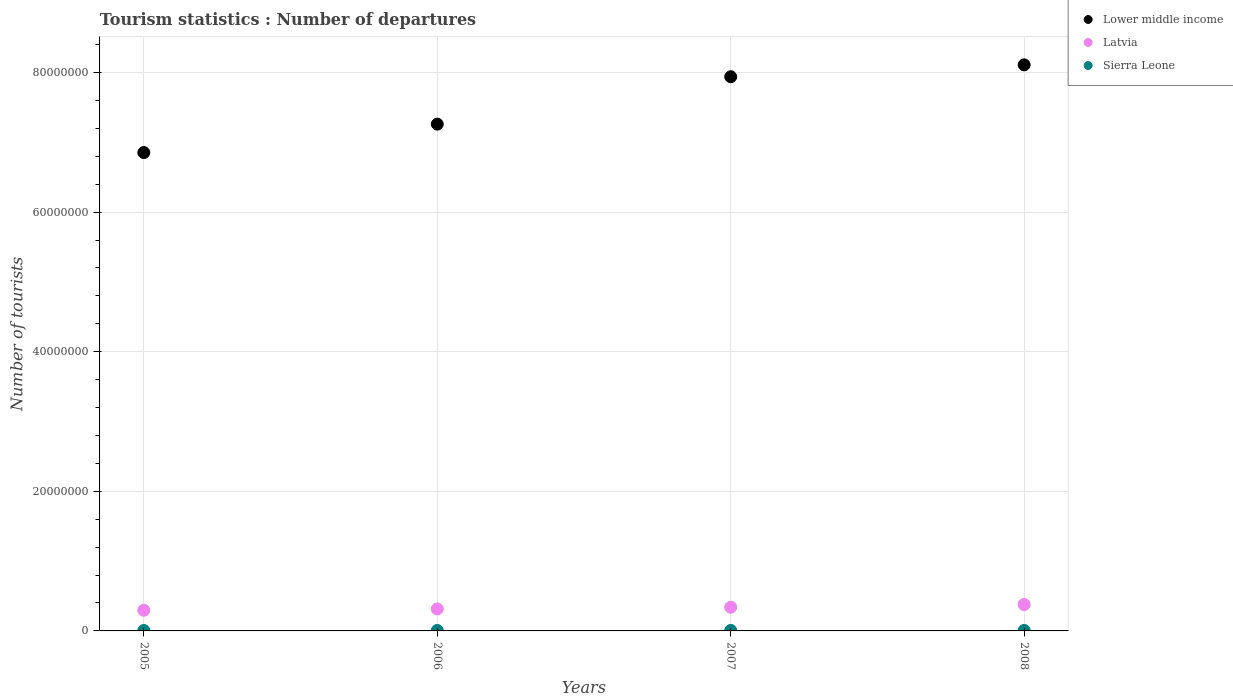How many different coloured dotlines are there?
Provide a succinct answer. 3. What is the number of tourist departures in Sierra Leone in 2006?
Give a very brief answer. 6.70e+04. Across all years, what is the maximum number of tourist departures in Latvia?
Give a very brief answer. 3.78e+06. Across all years, what is the minimum number of tourist departures in Lower middle income?
Offer a very short reply. 6.85e+07. What is the total number of tourist departures in Latvia in the graph?
Your answer should be compact. 1.33e+07. What is the difference between the number of tourist departures in Sierra Leone in 2005 and that in 2006?
Ensure brevity in your answer.  -4000. What is the difference between the number of tourist departures in Sierra Leone in 2007 and the number of tourist departures in Lower middle income in 2008?
Your answer should be compact. -8.10e+07. What is the average number of tourist departures in Latvia per year?
Ensure brevity in your answer.  3.32e+06. In the year 2008, what is the difference between the number of tourist departures in Lower middle income and number of tourist departures in Sierra Leone?
Make the answer very short. 8.10e+07. In how many years, is the number of tourist departures in Sierra Leone greater than 68000000?
Offer a very short reply. 0. What is the ratio of the number of tourist departures in Sierra Leone in 2005 to that in 2006?
Provide a succinct answer. 0.94. Is the number of tourist departures in Latvia in 2007 less than that in 2008?
Make the answer very short. Yes. What is the difference between the highest and the second highest number of tourist departures in Sierra Leone?
Keep it short and to the point. 2000. What is the difference between the highest and the lowest number of tourist departures in Lower middle income?
Offer a terse response. 1.26e+07. In how many years, is the number of tourist departures in Latvia greater than the average number of tourist departures in Latvia taken over all years?
Offer a very short reply. 2. Is the sum of the number of tourist departures in Lower middle income in 2006 and 2008 greater than the maximum number of tourist departures in Latvia across all years?
Make the answer very short. Yes. Does the graph contain any zero values?
Make the answer very short. No. How many legend labels are there?
Provide a succinct answer. 3. What is the title of the graph?
Your response must be concise. Tourism statistics : Number of departures. Does "Germany" appear as one of the legend labels in the graph?
Provide a succinct answer. No. What is the label or title of the X-axis?
Give a very brief answer. Years. What is the label or title of the Y-axis?
Keep it short and to the point. Number of tourists. What is the Number of tourists of Lower middle income in 2005?
Your answer should be compact. 6.85e+07. What is the Number of tourists in Latvia in 2005?
Your answer should be very brief. 2.96e+06. What is the Number of tourists of Sierra Leone in 2005?
Offer a very short reply. 6.30e+04. What is the Number of tourists of Lower middle income in 2006?
Offer a terse response. 7.26e+07. What is the Number of tourists in Latvia in 2006?
Provide a succinct answer. 3.15e+06. What is the Number of tourists in Sierra Leone in 2006?
Give a very brief answer. 6.70e+04. What is the Number of tourists in Lower middle income in 2007?
Give a very brief answer. 7.94e+07. What is the Number of tourists in Latvia in 2007?
Provide a succinct answer. 3.40e+06. What is the Number of tourists of Sierra Leone in 2007?
Make the answer very short. 7.10e+04. What is the Number of tourists in Lower middle income in 2008?
Keep it short and to the point. 8.11e+07. What is the Number of tourists of Latvia in 2008?
Your response must be concise. 3.78e+06. What is the Number of tourists in Sierra Leone in 2008?
Ensure brevity in your answer.  7.30e+04. Across all years, what is the maximum Number of tourists of Lower middle income?
Your answer should be compact. 8.11e+07. Across all years, what is the maximum Number of tourists in Latvia?
Your answer should be very brief. 3.78e+06. Across all years, what is the maximum Number of tourists in Sierra Leone?
Your answer should be very brief. 7.30e+04. Across all years, what is the minimum Number of tourists of Lower middle income?
Ensure brevity in your answer.  6.85e+07. Across all years, what is the minimum Number of tourists of Latvia?
Provide a succinct answer. 2.96e+06. Across all years, what is the minimum Number of tourists of Sierra Leone?
Ensure brevity in your answer.  6.30e+04. What is the total Number of tourists of Lower middle income in the graph?
Offer a very short reply. 3.02e+08. What is the total Number of tourists of Latvia in the graph?
Offer a very short reply. 1.33e+07. What is the total Number of tourists in Sierra Leone in the graph?
Give a very brief answer. 2.74e+05. What is the difference between the Number of tourists in Lower middle income in 2005 and that in 2006?
Ensure brevity in your answer.  -4.07e+06. What is the difference between the Number of tourists of Latvia in 2005 and that in 2006?
Your answer should be very brief. -1.92e+05. What is the difference between the Number of tourists in Sierra Leone in 2005 and that in 2006?
Your answer should be very brief. -4000. What is the difference between the Number of tourists in Lower middle income in 2005 and that in 2007?
Provide a short and direct response. -1.09e+07. What is the difference between the Number of tourists in Latvia in 2005 and that in 2007?
Your answer should be very brief. -4.39e+05. What is the difference between the Number of tourists of Sierra Leone in 2005 and that in 2007?
Give a very brief answer. -8000. What is the difference between the Number of tourists of Lower middle income in 2005 and that in 2008?
Make the answer very short. -1.26e+07. What is the difference between the Number of tourists in Latvia in 2005 and that in 2008?
Your response must be concise. -8.23e+05. What is the difference between the Number of tourists of Lower middle income in 2006 and that in 2007?
Give a very brief answer. -6.79e+06. What is the difference between the Number of tourists of Latvia in 2006 and that in 2007?
Ensure brevity in your answer.  -2.47e+05. What is the difference between the Number of tourists in Sierra Leone in 2006 and that in 2007?
Offer a very short reply. -4000. What is the difference between the Number of tourists in Lower middle income in 2006 and that in 2008?
Make the answer very short. -8.49e+06. What is the difference between the Number of tourists in Latvia in 2006 and that in 2008?
Provide a short and direct response. -6.31e+05. What is the difference between the Number of tourists of Sierra Leone in 2006 and that in 2008?
Keep it short and to the point. -6000. What is the difference between the Number of tourists of Lower middle income in 2007 and that in 2008?
Keep it short and to the point. -1.70e+06. What is the difference between the Number of tourists in Latvia in 2007 and that in 2008?
Give a very brief answer. -3.84e+05. What is the difference between the Number of tourists in Sierra Leone in 2007 and that in 2008?
Make the answer very short. -2000. What is the difference between the Number of tourists in Lower middle income in 2005 and the Number of tourists in Latvia in 2006?
Give a very brief answer. 6.54e+07. What is the difference between the Number of tourists in Lower middle income in 2005 and the Number of tourists in Sierra Leone in 2006?
Your answer should be compact. 6.85e+07. What is the difference between the Number of tourists of Latvia in 2005 and the Number of tourists of Sierra Leone in 2006?
Keep it short and to the point. 2.89e+06. What is the difference between the Number of tourists of Lower middle income in 2005 and the Number of tourists of Latvia in 2007?
Offer a very short reply. 6.51e+07. What is the difference between the Number of tourists in Lower middle income in 2005 and the Number of tourists in Sierra Leone in 2007?
Your answer should be very brief. 6.85e+07. What is the difference between the Number of tourists of Latvia in 2005 and the Number of tourists of Sierra Leone in 2007?
Offer a very short reply. 2.89e+06. What is the difference between the Number of tourists in Lower middle income in 2005 and the Number of tourists in Latvia in 2008?
Make the answer very short. 6.47e+07. What is the difference between the Number of tourists in Lower middle income in 2005 and the Number of tourists in Sierra Leone in 2008?
Offer a terse response. 6.85e+07. What is the difference between the Number of tourists in Latvia in 2005 and the Number of tourists in Sierra Leone in 2008?
Make the answer very short. 2.89e+06. What is the difference between the Number of tourists of Lower middle income in 2006 and the Number of tourists of Latvia in 2007?
Your response must be concise. 6.92e+07. What is the difference between the Number of tourists in Lower middle income in 2006 and the Number of tourists in Sierra Leone in 2007?
Give a very brief answer. 7.25e+07. What is the difference between the Number of tourists in Latvia in 2006 and the Number of tourists in Sierra Leone in 2007?
Provide a succinct answer. 3.08e+06. What is the difference between the Number of tourists of Lower middle income in 2006 and the Number of tourists of Latvia in 2008?
Provide a short and direct response. 6.88e+07. What is the difference between the Number of tourists of Lower middle income in 2006 and the Number of tourists of Sierra Leone in 2008?
Give a very brief answer. 7.25e+07. What is the difference between the Number of tourists in Latvia in 2006 and the Number of tourists in Sierra Leone in 2008?
Offer a terse response. 3.08e+06. What is the difference between the Number of tourists in Lower middle income in 2007 and the Number of tourists in Latvia in 2008?
Offer a terse response. 7.56e+07. What is the difference between the Number of tourists in Lower middle income in 2007 and the Number of tourists in Sierra Leone in 2008?
Your answer should be very brief. 7.93e+07. What is the difference between the Number of tourists of Latvia in 2007 and the Number of tourists of Sierra Leone in 2008?
Offer a terse response. 3.32e+06. What is the average Number of tourists in Lower middle income per year?
Make the answer very short. 7.54e+07. What is the average Number of tourists of Latvia per year?
Offer a terse response. 3.32e+06. What is the average Number of tourists in Sierra Leone per year?
Your response must be concise. 6.85e+04. In the year 2005, what is the difference between the Number of tourists of Lower middle income and Number of tourists of Latvia?
Your response must be concise. 6.56e+07. In the year 2005, what is the difference between the Number of tourists in Lower middle income and Number of tourists in Sierra Leone?
Provide a succinct answer. 6.85e+07. In the year 2005, what is the difference between the Number of tourists in Latvia and Number of tourists in Sierra Leone?
Keep it short and to the point. 2.90e+06. In the year 2006, what is the difference between the Number of tourists of Lower middle income and Number of tourists of Latvia?
Offer a very short reply. 6.94e+07. In the year 2006, what is the difference between the Number of tourists of Lower middle income and Number of tourists of Sierra Leone?
Provide a succinct answer. 7.25e+07. In the year 2006, what is the difference between the Number of tourists in Latvia and Number of tourists in Sierra Leone?
Ensure brevity in your answer.  3.08e+06. In the year 2007, what is the difference between the Number of tourists in Lower middle income and Number of tourists in Latvia?
Make the answer very short. 7.60e+07. In the year 2007, what is the difference between the Number of tourists in Lower middle income and Number of tourists in Sierra Leone?
Your answer should be compact. 7.93e+07. In the year 2007, what is the difference between the Number of tourists in Latvia and Number of tourists in Sierra Leone?
Keep it short and to the point. 3.33e+06. In the year 2008, what is the difference between the Number of tourists in Lower middle income and Number of tourists in Latvia?
Offer a very short reply. 7.73e+07. In the year 2008, what is the difference between the Number of tourists of Lower middle income and Number of tourists of Sierra Leone?
Provide a short and direct response. 8.10e+07. In the year 2008, what is the difference between the Number of tourists of Latvia and Number of tourists of Sierra Leone?
Your answer should be very brief. 3.71e+06. What is the ratio of the Number of tourists of Lower middle income in 2005 to that in 2006?
Offer a terse response. 0.94. What is the ratio of the Number of tourists of Latvia in 2005 to that in 2006?
Make the answer very short. 0.94. What is the ratio of the Number of tourists of Sierra Leone in 2005 to that in 2006?
Your answer should be very brief. 0.94. What is the ratio of the Number of tourists of Lower middle income in 2005 to that in 2007?
Give a very brief answer. 0.86. What is the ratio of the Number of tourists of Latvia in 2005 to that in 2007?
Keep it short and to the point. 0.87. What is the ratio of the Number of tourists of Sierra Leone in 2005 to that in 2007?
Keep it short and to the point. 0.89. What is the ratio of the Number of tourists in Lower middle income in 2005 to that in 2008?
Keep it short and to the point. 0.85. What is the ratio of the Number of tourists in Latvia in 2005 to that in 2008?
Your response must be concise. 0.78. What is the ratio of the Number of tourists of Sierra Leone in 2005 to that in 2008?
Your answer should be very brief. 0.86. What is the ratio of the Number of tourists in Lower middle income in 2006 to that in 2007?
Keep it short and to the point. 0.91. What is the ratio of the Number of tourists in Latvia in 2006 to that in 2007?
Give a very brief answer. 0.93. What is the ratio of the Number of tourists in Sierra Leone in 2006 to that in 2007?
Make the answer very short. 0.94. What is the ratio of the Number of tourists in Lower middle income in 2006 to that in 2008?
Give a very brief answer. 0.9. What is the ratio of the Number of tourists of Latvia in 2006 to that in 2008?
Your answer should be very brief. 0.83. What is the ratio of the Number of tourists of Sierra Leone in 2006 to that in 2008?
Ensure brevity in your answer.  0.92. What is the ratio of the Number of tourists in Latvia in 2007 to that in 2008?
Offer a terse response. 0.9. What is the ratio of the Number of tourists in Sierra Leone in 2007 to that in 2008?
Give a very brief answer. 0.97. What is the difference between the highest and the second highest Number of tourists in Lower middle income?
Keep it short and to the point. 1.70e+06. What is the difference between the highest and the second highest Number of tourists of Latvia?
Give a very brief answer. 3.84e+05. What is the difference between the highest and the lowest Number of tourists of Lower middle income?
Keep it short and to the point. 1.26e+07. What is the difference between the highest and the lowest Number of tourists of Latvia?
Provide a short and direct response. 8.23e+05. 